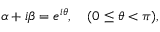<formula> <loc_0><loc_0><loc_500><loc_500>\alpha + i \beta = e ^ { i \theta } , ( 0 \leq \theta < \pi ) ,</formula> 